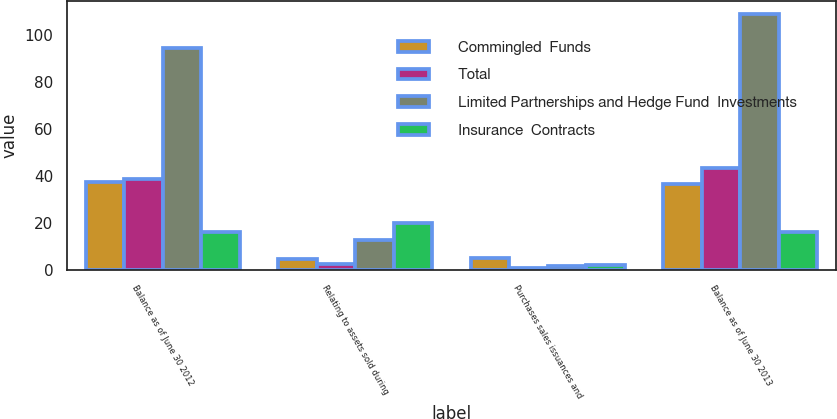Convert chart. <chart><loc_0><loc_0><loc_500><loc_500><stacked_bar_chart><ecel><fcel>Balance as of June 30 2012<fcel>Relating to assets sold during<fcel>Purchases sales issuances and<fcel>Balance as of June 30 2013<nl><fcel>Commingled  Funds<fcel>37.7<fcel>4.8<fcel>5.2<fcel>36.6<nl><fcel>Total<fcel>38.7<fcel>2.4<fcel>1.1<fcel>43.6<nl><fcel>Limited Partnerships and Hedge Fund  Investments<fcel>94.5<fcel>12.7<fcel>1.9<fcel>109.2<nl><fcel>Insurance  Contracts<fcel>16.3<fcel>19.9<fcel>2.2<fcel>16.3<nl></chart> 